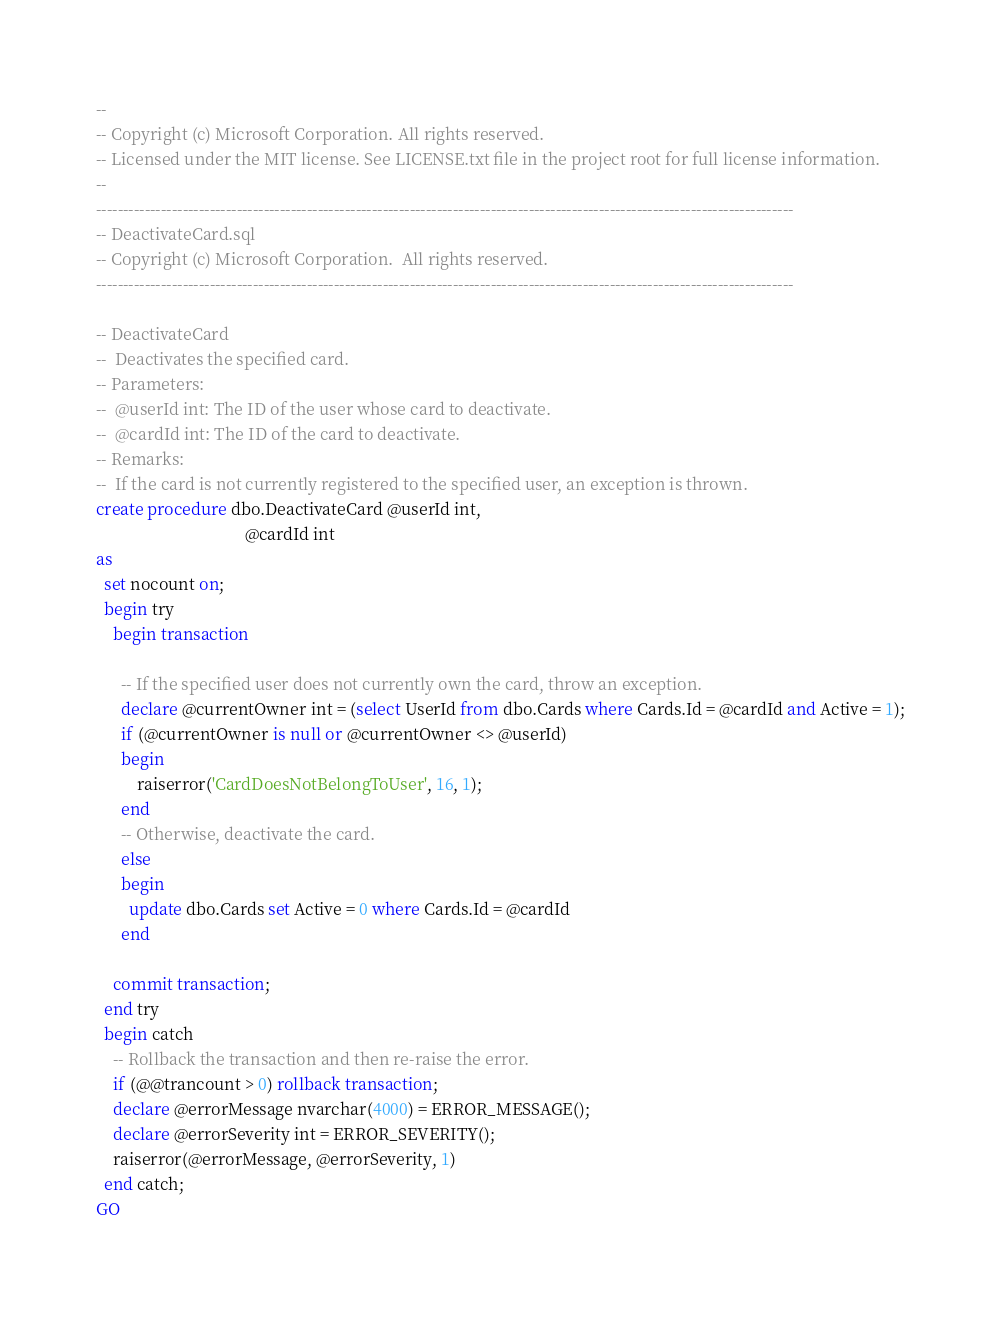Convert code to text. <code><loc_0><loc_0><loc_500><loc_500><_SQL_>--
-- Copyright (c) Microsoft Corporation. All rights reserved. 
-- Licensed under the MIT license. See LICENSE.txt file in the project root for full license information.
--
---------------------------------------------------------------------------------------------------------------------------------
-- DeactivateCard.sql
-- Copyright (c) Microsoft Corporation.  All rights reserved.  
---------------------------------------------------------------------------------------------------------------------------------

-- DeactivateCard
--  Deactivates the specified card.
-- Parameters:
--  @userId int: The ID of the user whose card to deactivate.
--  @cardId int: The ID of the card to deactivate.
-- Remarks:
--  If the card is not currently registered to the specified user, an exception is thrown.
create procedure dbo.DeactivateCard @userId int,
                                    @cardId int
as
  set nocount on;
  begin try
    begin transaction

      -- If the specified user does not currently own the card, throw an exception.
      declare @currentOwner int = (select UserId from dbo.Cards where Cards.Id = @cardId and Active = 1);
      if (@currentOwner is null or @currentOwner <> @userId)
      begin
          raiserror('CardDoesNotBelongToUser', 16, 1);
      end
      -- Otherwise, deactivate the card.
      else
      begin
        update dbo.Cards set Active = 0 where Cards.Id = @cardId
      end

    commit transaction;
  end try
  begin catch
    -- Rollback the transaction and then re-raise the error.
    if (@@trancount > 0) rollback transaction;
    declare @errorMessage nvarchar(4000) = ERROR_MESSAGE();
    declare @errorSeverity int = ERROR_SEVERITY();
    raiserror(@errorMessage, @errorSeverity, 1)
  end catch;
GO</code> 